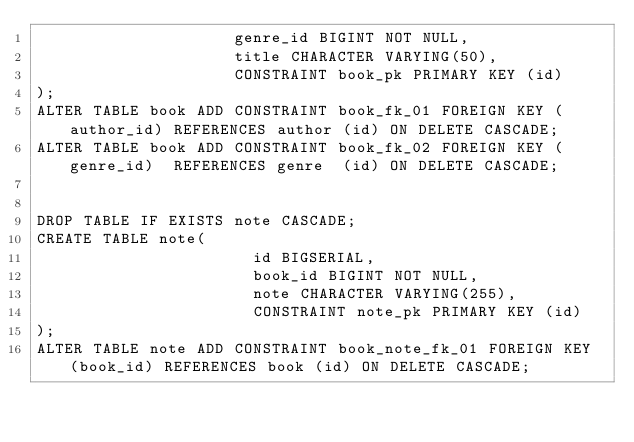Convert code to text. <code><loc_0><loc_0><loc_500><loc_500><_SQL_>                     genre_id BIGINT NOT NULL,
                     title CHARACTER VARYING(50),
                     CONSTRAINT book_pk PRIMARY KEY (id)
);
ALTER TABLE book ADD CONSTRAINT book_fk_01 FOREIGN KEY (author_id) REFERENCES author (id) ON DELETE CASCADE;
ALTER TABLE book ADD CONSTRAINT book_fk_02 FOREIGN KEY (genre_id)  REFERENCES genre  (id) ON DELETE CASCADE;


DROP TABLE IF EXISTS note CASCADE;
CREATE TABLE note(
                       id BIGSERIAL,
                       book_id BIGINT NOT NULL,
                       note CHARACTER VARYING(255),
                       CONSTRAINT note_pk PRIMARY KEY (id)
);
ALTER TABLE note ADD CONSTRAINT book_note_fk_01 FOREIGN KEY (book_id) REFERENCES book (id) ON DELETE CASCADE;

</code> 